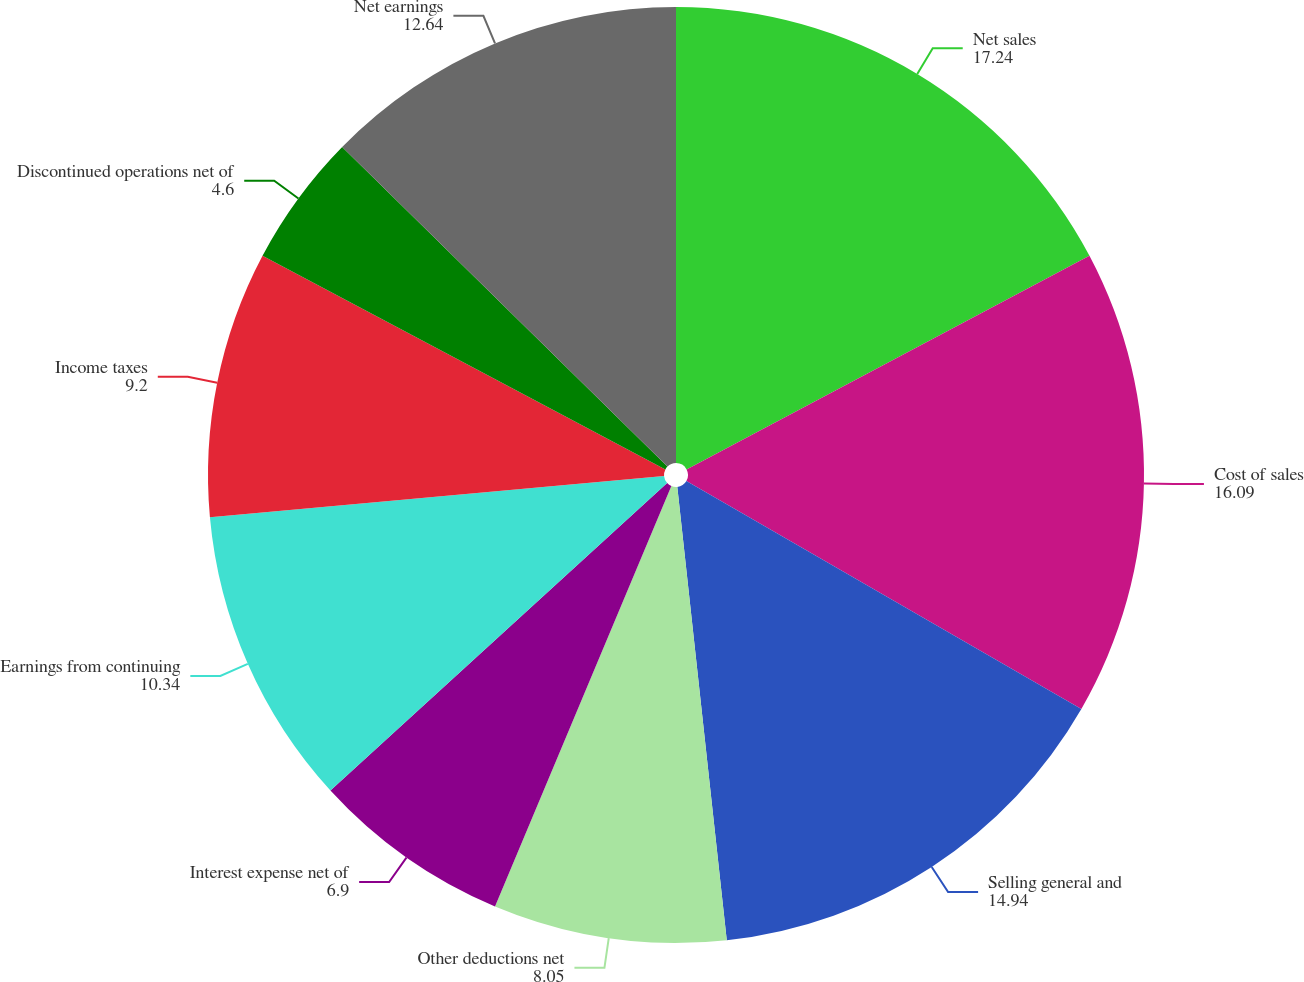<chart> <loc_0><loc_0><loc_500><loc_500><pie_chart><fcel>Net sales<fcel>Cost of sales<fcel>Selling general and<fcel>Other deductions net<fcel>Interest expense net of<fcel>Earnings from continuing<fcel>Income taxes<fcel>Discontinued operations net of<fcel>Net earnings<nl><fcel>17.24%<fcel>16.09%<fcel>14.94%<fcel>8.05%<fcel>6.9%<fcel>10.34%<fcel>9.2%<fcel>4.6%<fcel>12.64%<nl></chart> 